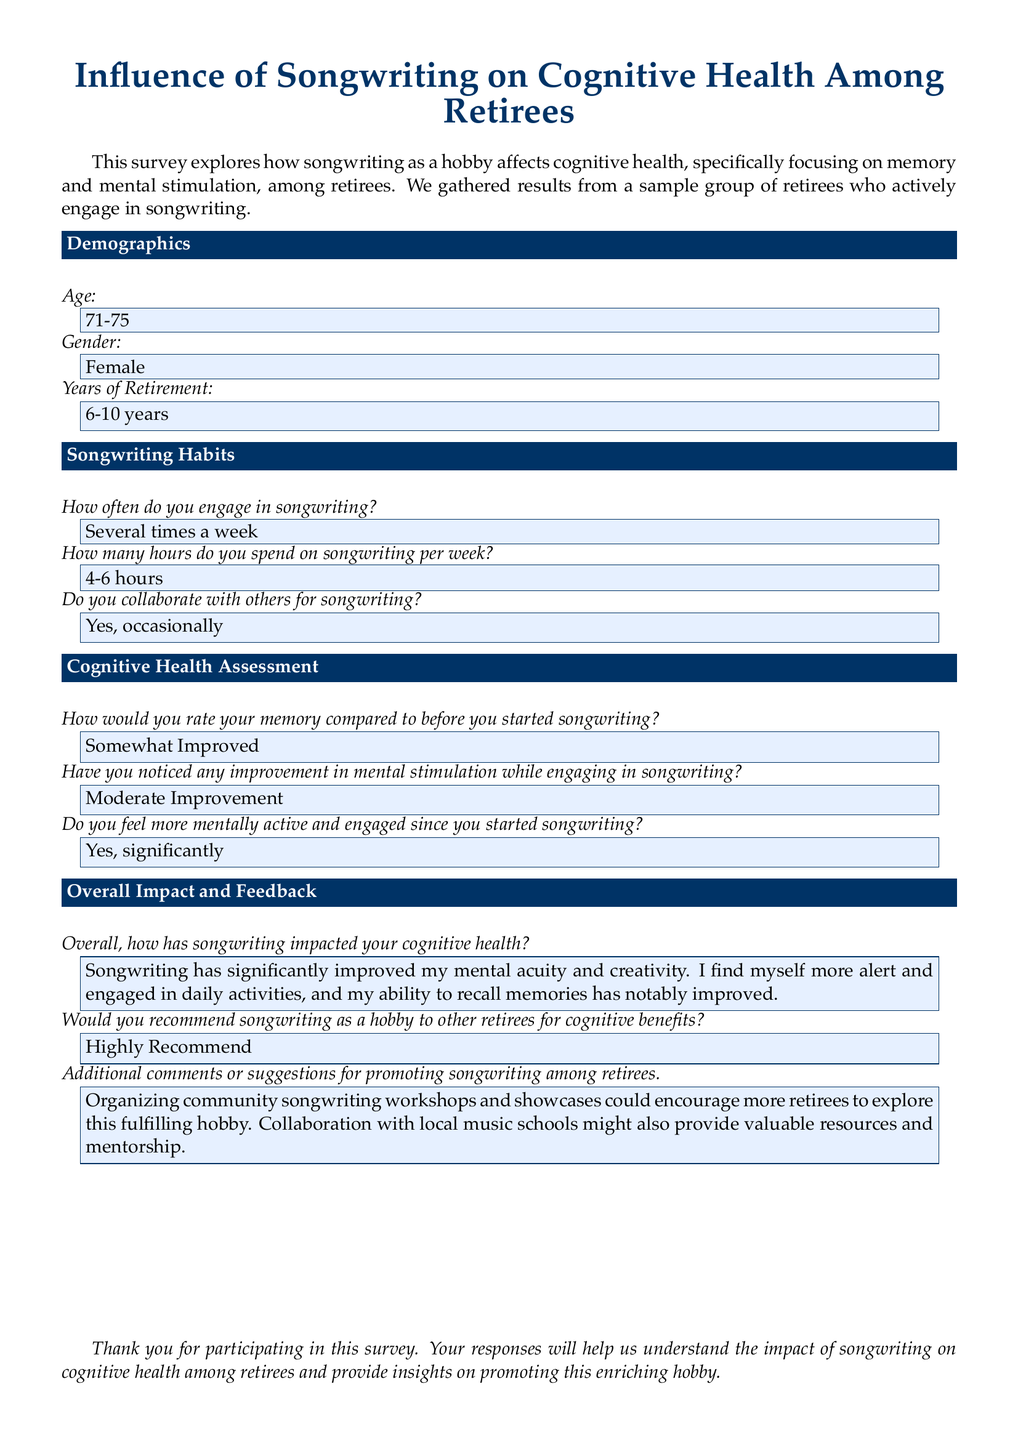What is the age range of the respondents? The age range of the respondents is found in the demographics section where it states "Age: 71-75."
Answer: 71-75 How many years have the respondents been retired? The years of retirement for the respondents is stated in the demographics section as "Years of Retirement: 6-10 years."
Answer: 6-10 years How often do the respondents engage in songwriting? The frequency of songwriting engagement is specified as "Several times a week" in the songwriting habits section.
Answer: Several times a week What is the perceived impact of songwriting on memory? The cognitive health assessment includes a response stating "Somewhat Improved," indicating the perceived impact on memory.
Answer: Somewhat Improved Do the respondents feel mentally active since starting songwriting? This is indicated in the cognitive health assessment where the response is "Yes, significantly."
Answer: Yes, significantly What is the overall recommendation for songwriting as a hobby? In the overall impact and feedback section, the recommendation is stated as "Highly Recommend."
Answer: Highly Recommend What do respondents suggest for promoting songwriting among retirees? The additional comments section provides suggestions, stating "Organizing community songwriting workshops and showcases..."
Answer: Organizing community songwriting workshops and showcases What is the average number of hours spent on songwriting per week? The average number of hours is found in the songwriting habits section, where it states "4-6 hours."
Answer: 4-6 hours 